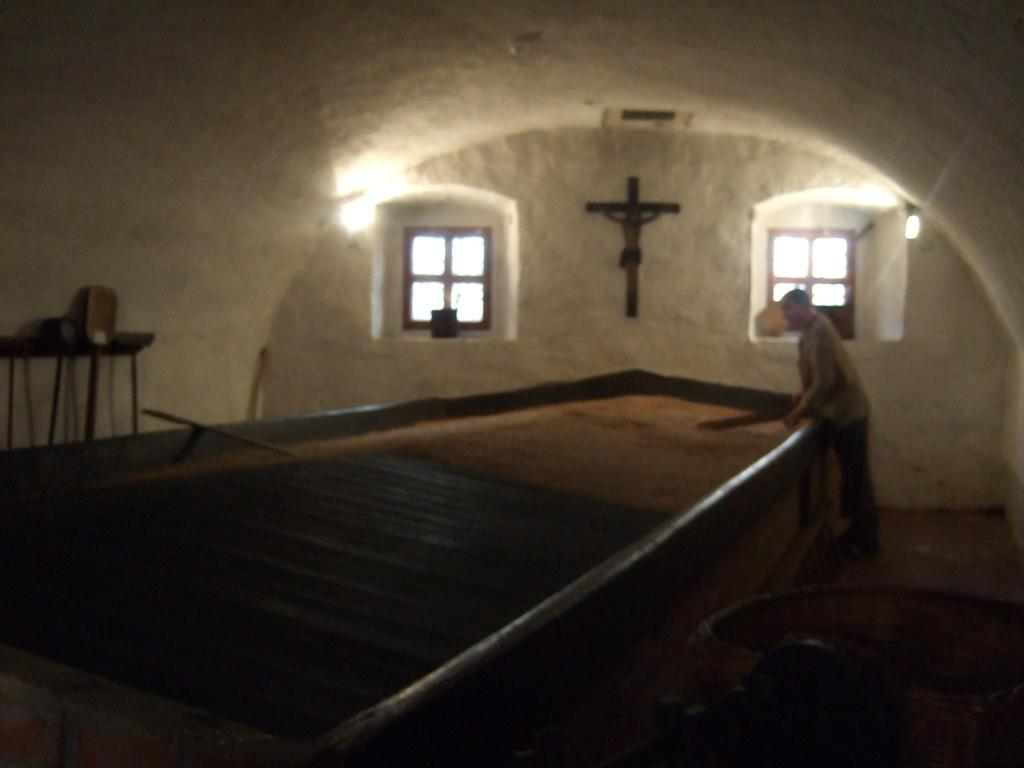Who is present in the image? There is a person in the image. What is the person doing in the image? The person is standing in front of a table. What is the person holding in his hand? The person is holding a stick in his hand. What can be seen in the background of the image? There are two windows, a statue on the wall, and a set of lights in the background of the image. What type of mist is covering the person in the image? There is no mist present in the image; the person is standing in front of a table with clear visibility. 